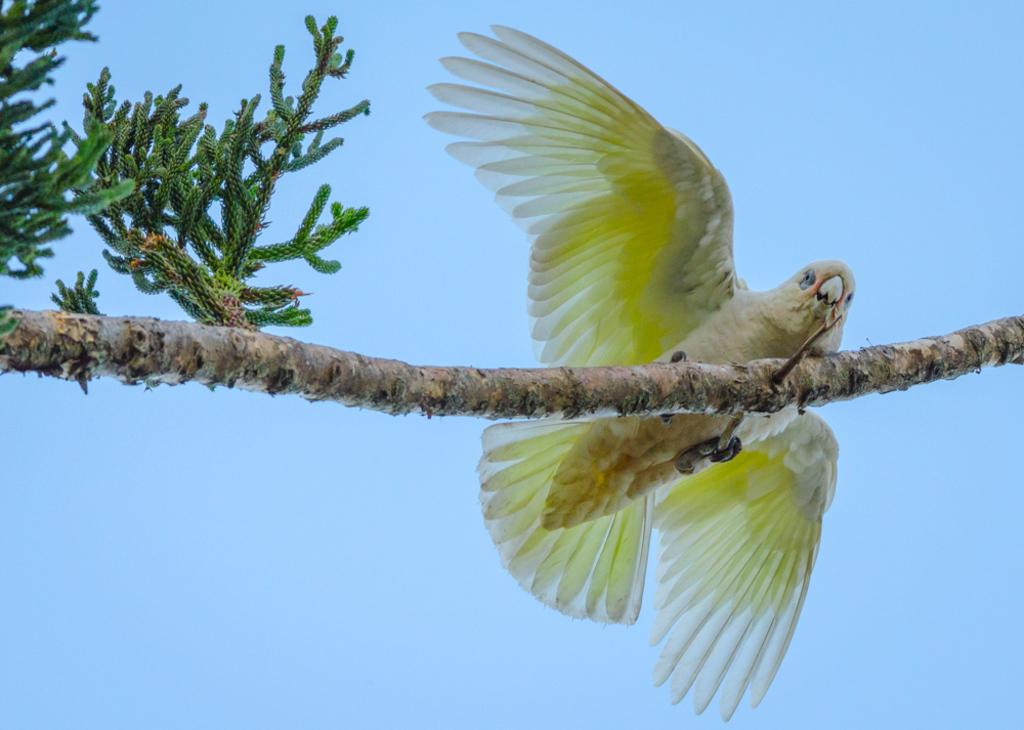What type of animal can be seen in the image? There is a yellow bird on a stem in the image. What is the condition of the sky in the image? The sky is clear in the image. What type of mist can be seen surrounding the bird in the image? There is no mist present in the image; the sky is clear. What does the bird's mom look like in the image? There is no bird's mom depicted in the image, as it only features the yellow bird on a stem. 